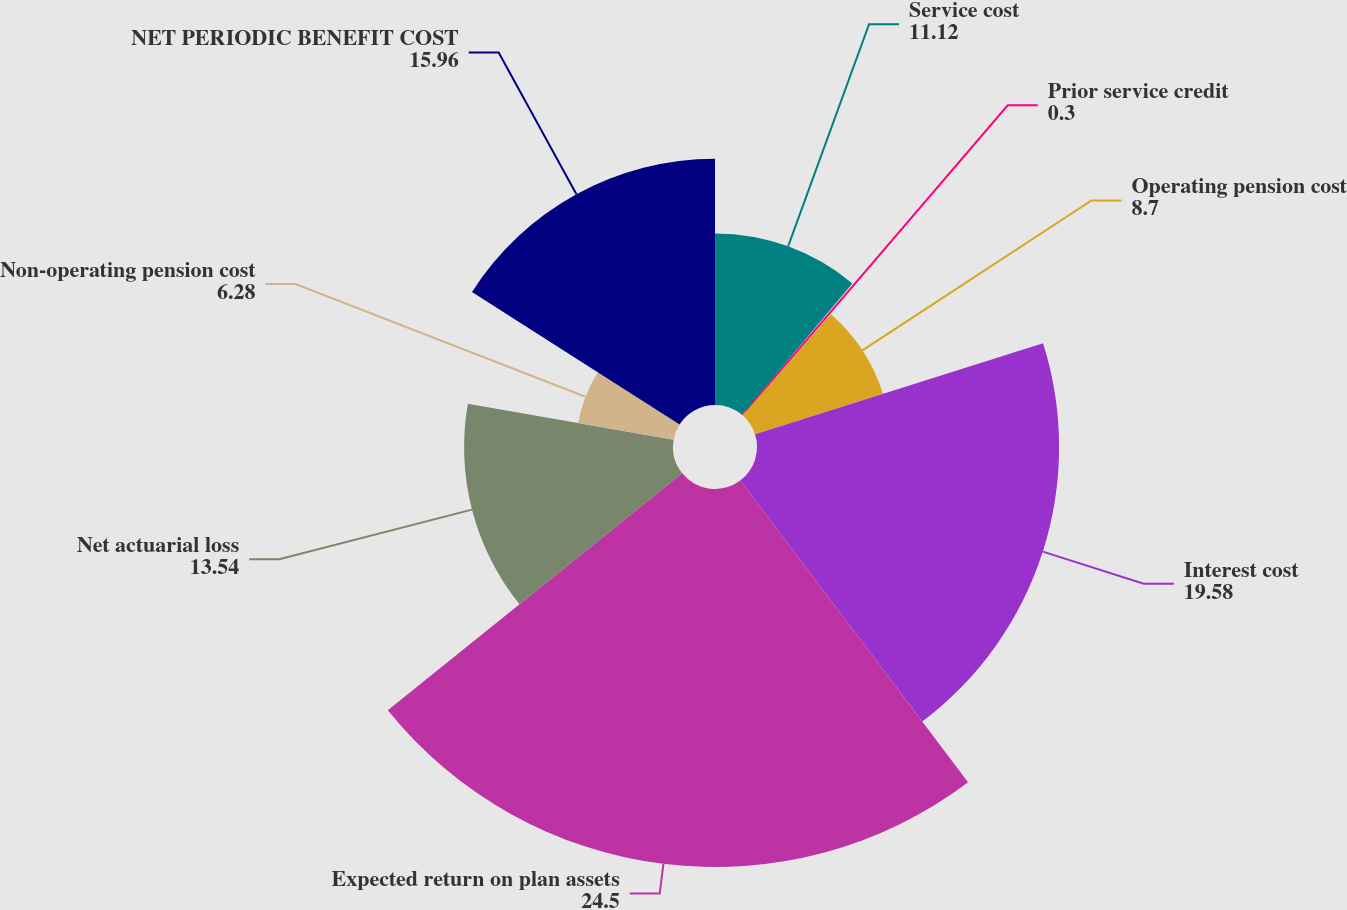<chart> <loc_0><loc_0><loc_500><loc_500><pie_chart><fcel>Service cost<fcel>Prior service credit<fcel>Operating pension cost<fcel>Interest cost<fcel>Expected return on plan assets<fcel>Net actuarial loss<fcel>Non-operating pension cost<fcel>NET PERIODIC BENEFIT COST<nl><fcel>11.12%<fcel>0.3%<fcel>8.7%<fcel>19.58%<fcel>24.5%<fcel>13.54%<fcel>6.28%<fcel>15.96%<nl></chart> 